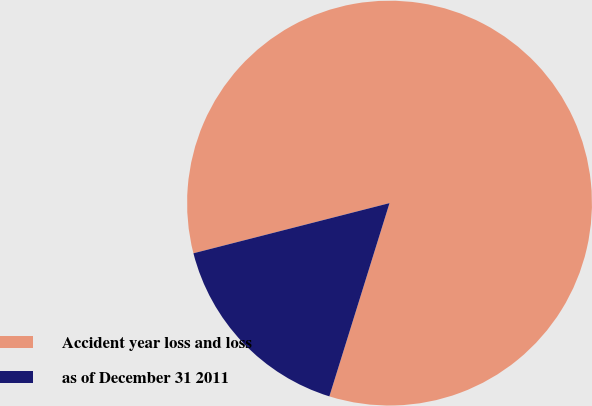Convert chart. <chart><loc_0><loc_0><loc_500><loc_500><pie_chart><fcel>Accident year loss and loss<fcel>as of December 31 2011<nl><fcel>83.79%<fcel>16.21%<nl></chart> 